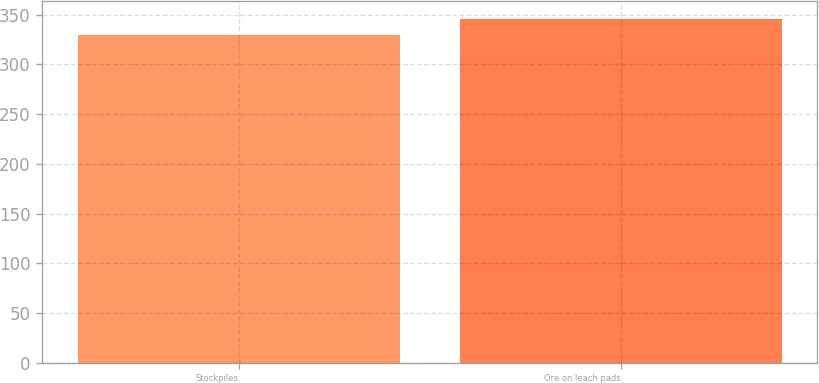<chart> <loc_0><loc_0><loc_500><loc_500><bar_chart><fcel>Stockpiles<fcel>Ore on leach pads<nl><fcel>330<fcel>346<nl></chart> 